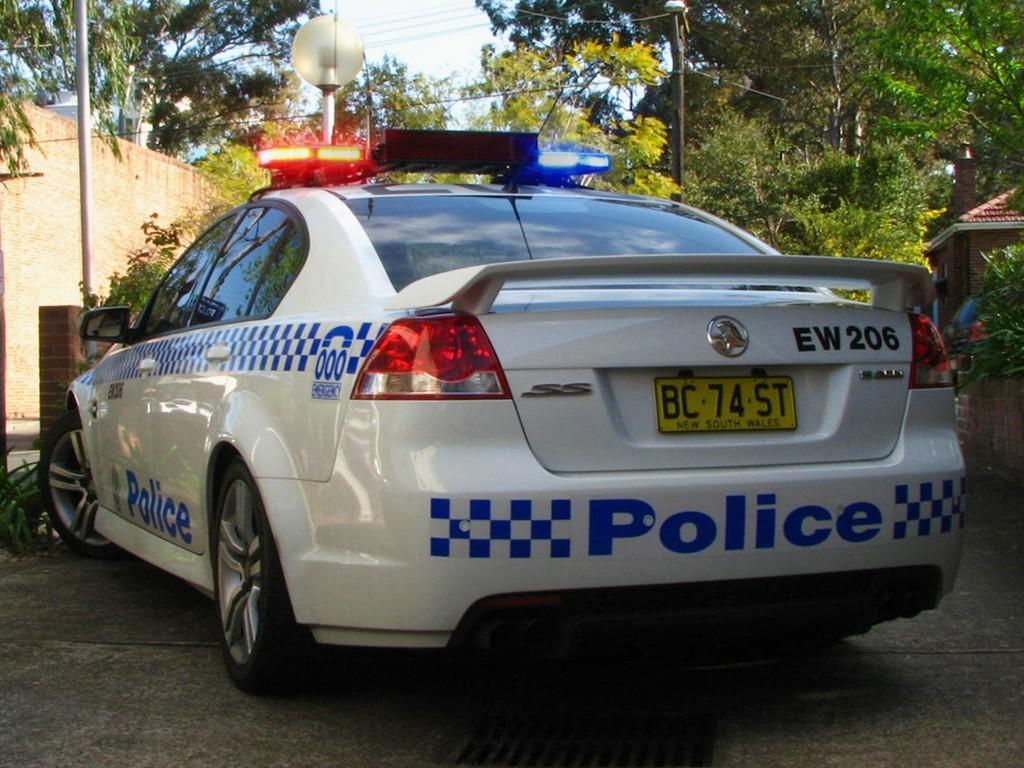Please provide a concise description of this image. In the image we can see the police car and trees. We can even see light poles, electric wires, road and the sky. It looks like a building. 